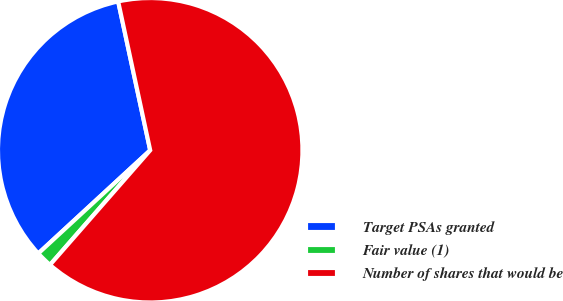<chart> <loc_0><loc_0><loc_500><loc_500><pie_chart><fcel>Target PSAs granted<fcel>Fair value (1)<fcel>Number of shares that would be<nl><fcel>33.48%<fcel>1.71%<fcel>64.81%<nl></chart> 